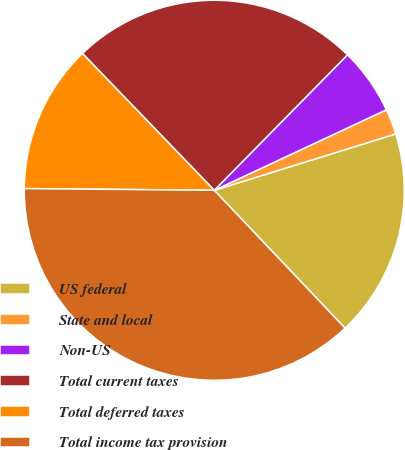<chart> <loc_0><loc_0><loc_500><loc_500><pie_chart><fcel>US federal<fcel>State and local<fcel>Non-US<fcel>Total current taxes<fcel>Total deferred taxes<fcel>Total income tax provision<nl><fcel>17.71%<fcel>2.17%<fcel>5.67%<fcel>24.57%<fcel>12.65%<fcel>37.22%<nl></chart> 